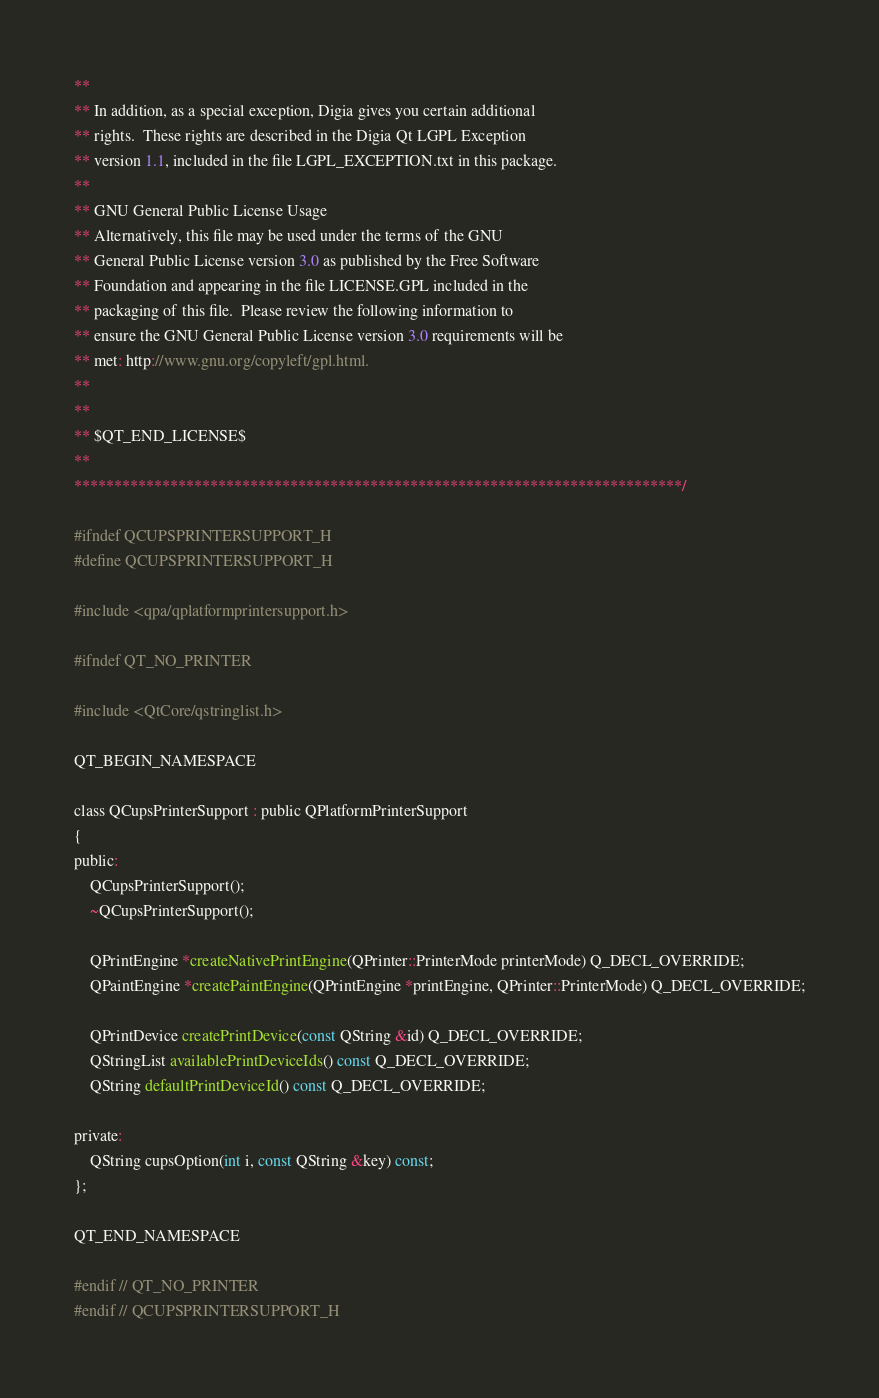Convert code to text. <code><loc_0><loc_0><loc_500><loc_500><_C_>**
** In addition, as a special exception, Digia gives you certain additional
** rights.  These rights are described in the Digia Qt LGPL Exception
** version 1.1, included in the file LGPL_EXCEPTION.txt in this package.
**
** GNU General Public License Usage
** Alternatively, this file may be used under the terms of the GNU
** General Public License version 3.0 as published by the Free Software
** Foundation and appearing in the file LICENSE.GPL included in the
** packaging of this file.  Please review the following information to
** ensure the GNU General Public License version 3.0 requirements will be
** met: http://www.gnu.org/copyleft/gpl.html.
**
**
** $QT_END_LICENSE$
**
****************************************************************************/

#ifndef QCUPSPRINTERSUPPORT_H
#define QCUPSPRINTERSUPPORT_H

#include <qpa/qplatformprintersupport.h>

#ifndef QT_NO_PRINTER

#include <QtCore/qstringlist.h>

QT_BEGIN_NAMESPACE

class QCupsPrinterSupport : public QPlatformPrinterSupport
{
public:
    QCupsPrinterSupport();
    ~QCupsPrinterSupport();

    QPrintEngine *createNativePrintEngine(QPrinter::PrinterMode printerMode) Q_DECL_OVERRIDE;
    QPaintEngine *createPaintEngine(QPrintEngine *printEngine, QPrinter::PrinterMode) Q_DECL_OVERRIDE;

    QPrintDevice createPrintDevice(const QString &id) Q_DECL_OVERRIDE;
    QStringList availablePrintDeviceIds() const Q_DECL_OVERRIDE;
    QString defaultPrintDeviceId() const Q_DECL_OVERRIDE;

private:
    QString cupsOption(int i, const QString &key) const;
};

QT_END_NAMESPACE

#endif // QT_NO_PRINTER
#endif // QCUPSPRINTERSUPPORT_H
</code> 